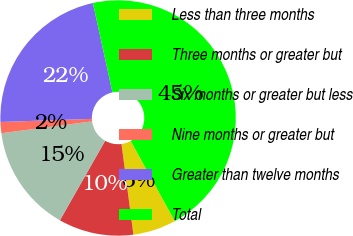Convert chart to OTSL. <chart><loc_0><loc_0><loc_500><loc_500><pie_chart><fcel>Less than three months<fcel>Three months or greater but<fcel>Six months or greater but less<fcel>Nine months or greater but<fcel>Greater than twelve months<fcel>Total<nl><fcel>5.92%<fcel>10.31%<fcel>14.7%<fcel>1.53%<fcel>22.11%<fcel>45.43%<nl></chart> 